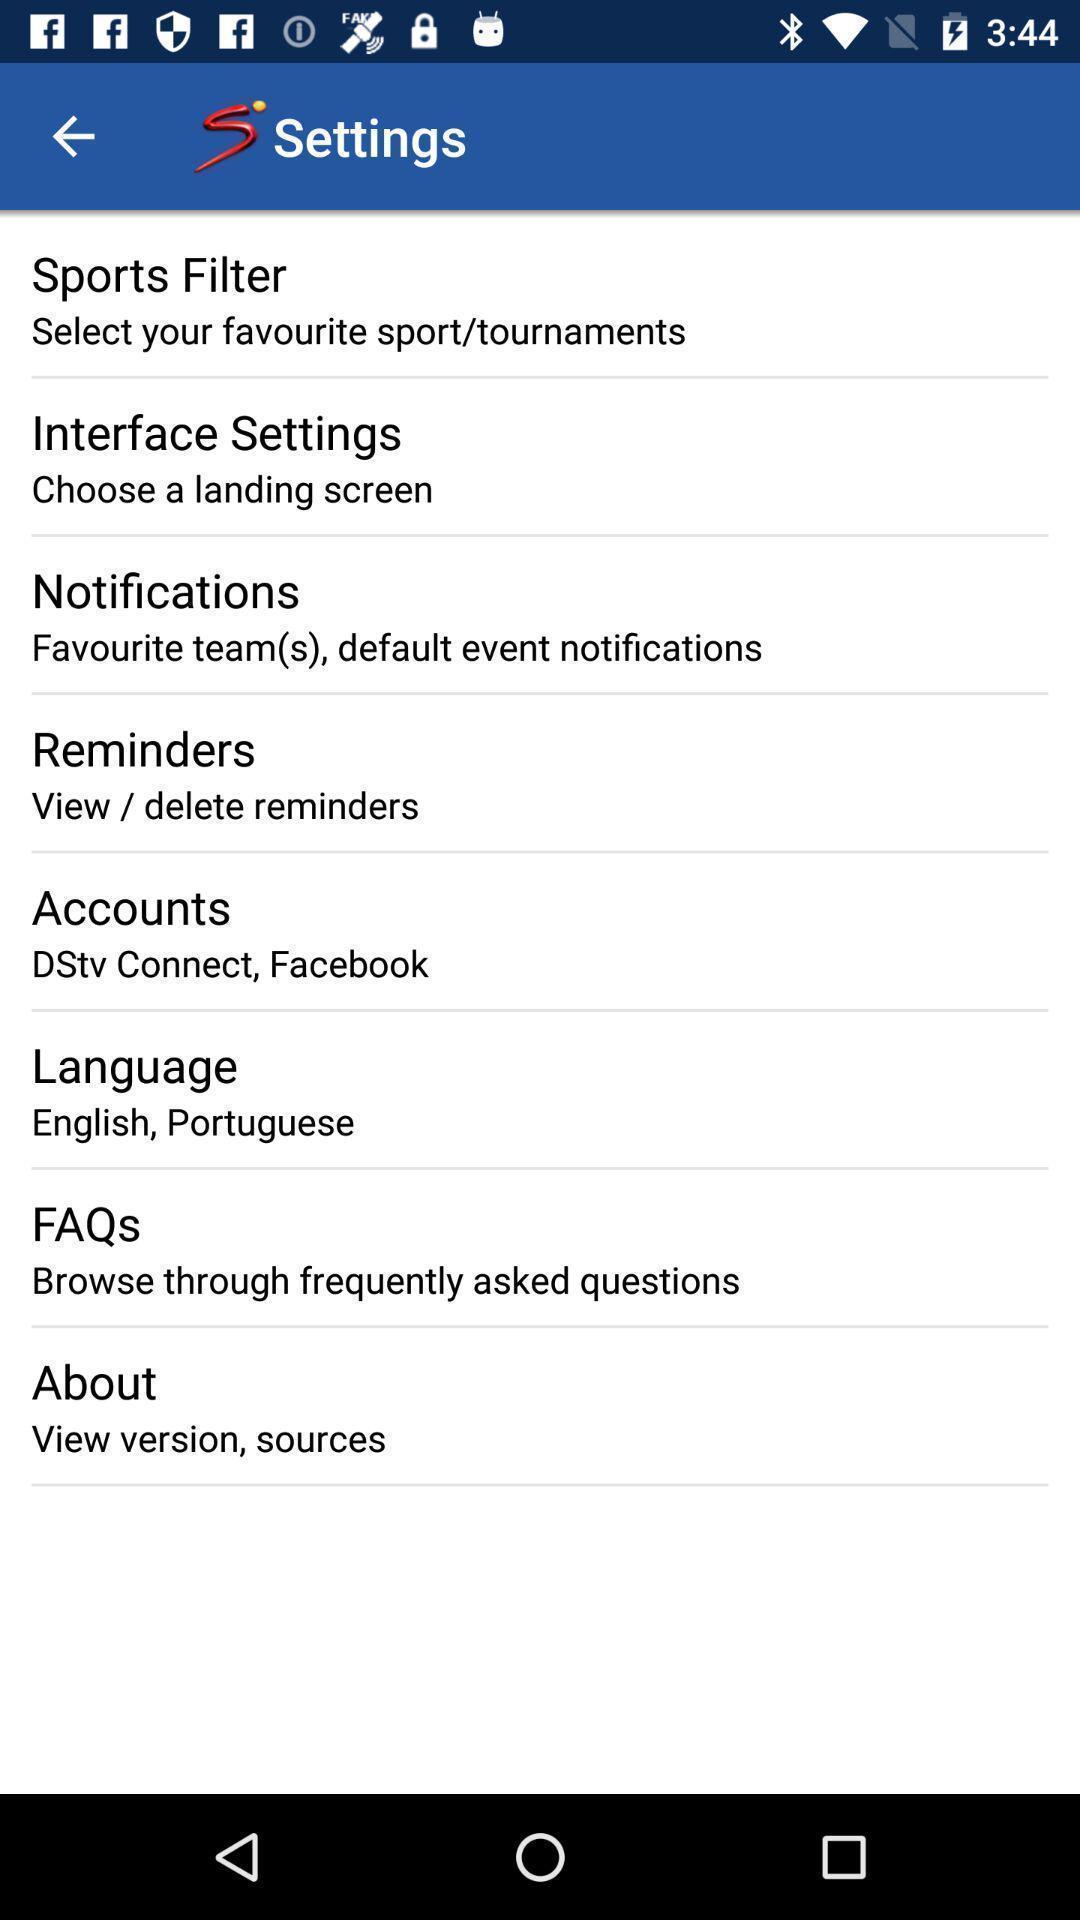Summarize the information in this screenshot. Settings page displayed of a sports app. 